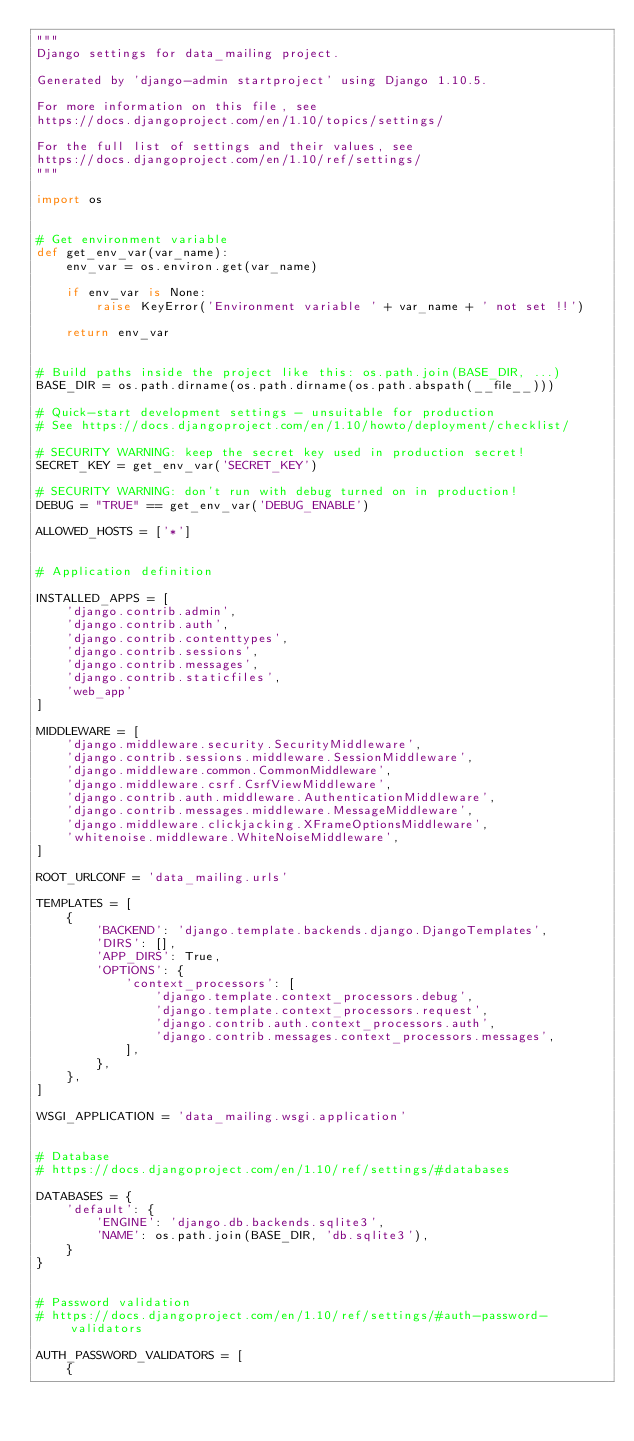<code> <loc_0><loc_0><loc_500><loc_500><_Python_>"""
Django settings for data_mailing project.

Generated by 'django-admin startproject' using Django 1.10.5.

For more information on this file, see
https://docs.djangoproject.com/en/1.10/topics/settings/

For the full list of settings and their values, see
https://docs.djangoproject.com/en/1.10/ref/settings/
"""

import os


# Get environment variable
def get_env_var(var_name):
    env_var = os.environ.get(var_name)

    if env_var is None:
        raise KeyError('Environment variable ' + var_name + ' not set !!')

    return env_var


# Build paths inside the project like this: os.path.join(BASE_DIR, ...)
BASE_DIR = os.path.dirname(os.path.dirname(os.path.abspath(__file__)))

# Quick-start development settings - unsuitable for production
# See https://docs.djangoproject.com/en/1.10/howto/deployment/checklist/

# SECURITY WARNING: keep the secret key used in production secret!
SECRET_KEY = get_env_var('SECRET_KEY')

# SECURITY WARNING: don't run with debug turned on in production!
DEBUG = "TRUE" == get_env_var('DEBUG_ENABLE')

ALLOWED_HOSTS = ['*']


# Application definition

INSTALLED_APPS = [
    'django.contrib.admin',
    'django.contrib.auth',
    'django.contrib.contenttypes',
    'django.contrib.sessions',
    'django.contrib.messages',
    'django.contrib.staticfiles',
    'web_app'
]

MIDDLEWARE = [
    'django.middleware.security.SecurityMiddleware',
    'django.contrib.sessions.middleware.SessionMiddleware',
    'django.middleware.common.CommonMiddleware',
    'django.middleware.csrf.CsrfViewMiddleware',
    'django.contrib.auth.middleware.AuthenticationMiddleware',
    'django.contrib.messages.middleware.MessageMiddleware',
    'django.middleware.clickjacking.XFrameOptionsMiddleware',
    'whitenoise.middleware.WhiteNoiseMiddleware',
]

ROOT_URLCONF = 'data_mailing.urls'

TEMPLATES = [
    {
        'BACKEND': 'django.template.backends.django.DjangoTemplates',
        'DIRS': [],
        'APP_DIRS': True,
        'OPTIONS': {
            'context_processors': [
                'django.template.context_processors.debug',
                'django.template.context_processors.request',
                'django.contrib.auth.context_processors.auth',
                'django.contrib.messages.context_processors.messages',
            ],
        },
    },
]

WSGI_APPLICATION = 'data_mailing.wsgi.application'


# Database
# https://docs.djangoproject.com/en/1.10/ref/settings/#databases

DATABASES = {
    'default': {
        'ENGINE': 'django.db.backends.sqlite3',
        'NAME': os.path.join(BASE_DIR, 'db.sqlite3'),
    }
}


# Password validation
# https://docs.djangoproject.com/en/1.10/ref/settings/#auth-password-validators

AUTH_PASSWORD_VALIDATORS = [
    {</code> 